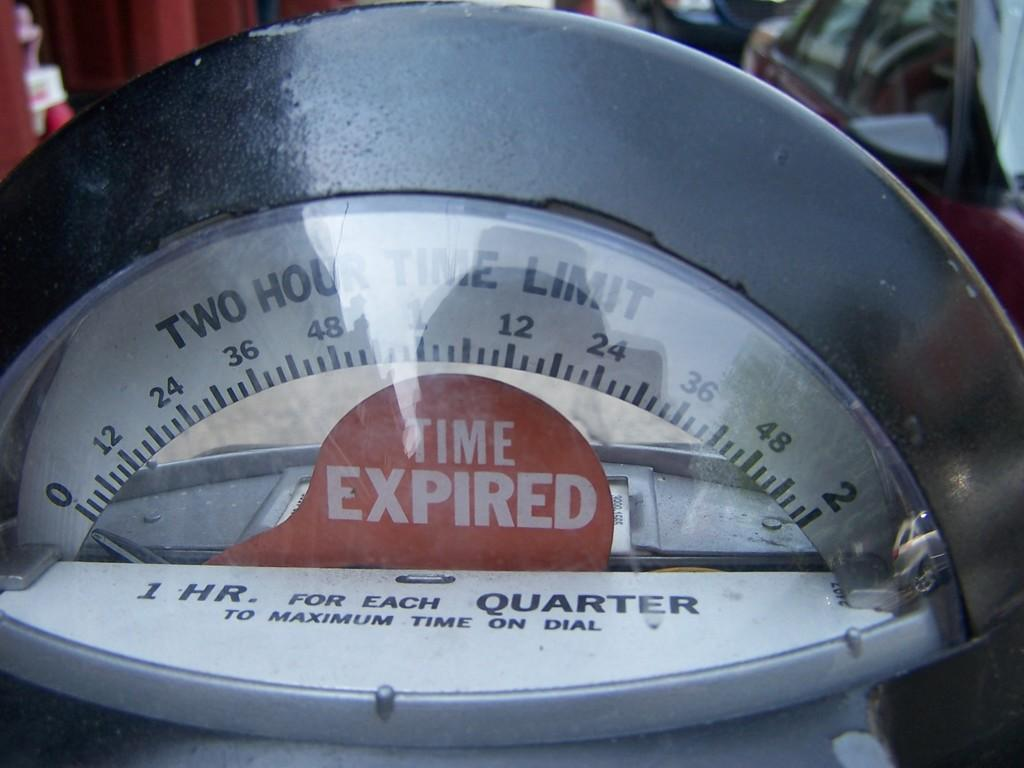What is the main subject of the image? The main subject of the image is a meteor. What else can be seen in the image besides the meteor? There is text and readings in the image, as well as vehicles visible at the top. What type of cake is being served at the event in the image? There is no event or cake present in the image; it features a meteor and related information. What button can be seen being pressed by the meteor in the image? There is no button or interaction with the meteor in the image; it is a static representation. 